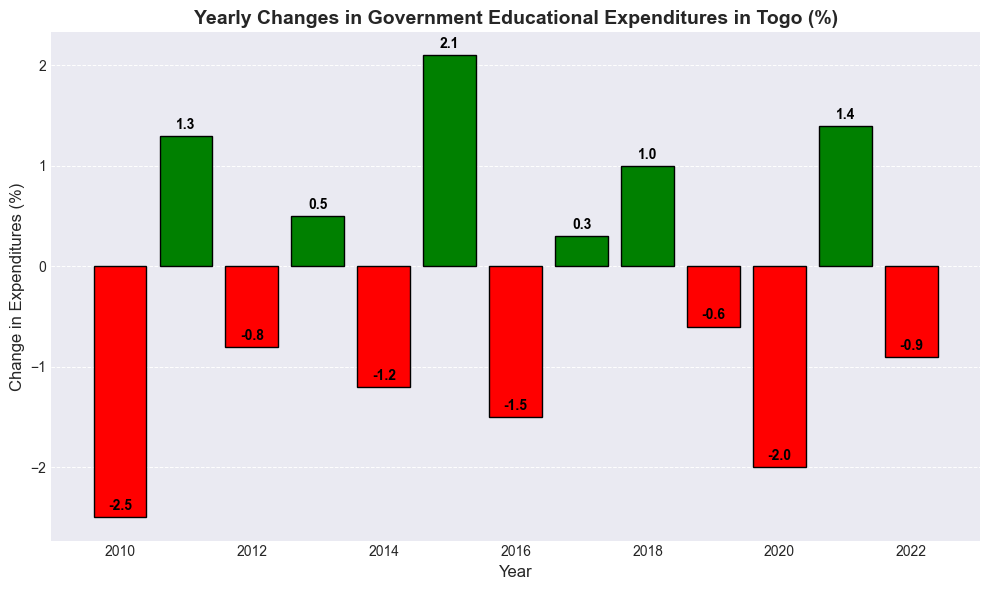Which year experienced the largest negative change in government educational expenditures? By examining the chart, the bar with the lowest height represents the largest negative value. This occurs in 2010 with a change of -2.5%.
Answer: 2010 Which years had positive changes in government educational expenditures consecutively? By looking at the bars in the chart, the years where the expenditures increased consecutively are from 2011 to 2013 and from 2017 to 2018. Thus, the period with consecutive positive changes is from 2011 to 2013.
Answer: 2011-2013 How many years had a decline in government educational expenditures? Counting the number of bars that are colored in red shows there are 7 years with negative changes (-2.5, -0.8, -1.2, -1.5, -0.6, -2.0, -0.9) indicating a decline.
Answer: 7 What was the average change in government educational expenditures over the decade (2010-2020)? The changes from 2010 to 2020 are: -2.5, 1.3, -0.8, 0.5, -1.2, 2.1, -1.5, 0.3, 1.0, -0.6, -2.0. Summing these gives -3.4. Dividing by 11 gives -3.4/11 ≈ -0.31.
Answer: -0.31% Which year had the smallest positive change in government educational expenditures? Observing the green bars representing positive changes, the smallest positive change is 2017 with 0.3%.
Answer: 2017 In which year did government educational expenditures decrease more than it did in 2022? Comparing the red bars, the years with a negative change greater than -0.9% in 2022 are 2010 with -2.5%, 2016 with -1.5%, and 2020 with -2.0%.
Answer: 2010, 2016, 2020 Which year showed the highest increase in educational expenditures? The tallest green bar represents the highest increase, which occurs in 2015 with an increase of 2.1%.
Answer: 2015 What is the total change in government educational expenditures from 2010 to 2015? The changes from 2010 to 2015 are -2.5%, 1.3%, -0.8%, 0.5%, -1.2%, and 2.1%. Summing these, -2.5 + 1.3 - 0.8 + 0.5 - 1.2 + 2.1 = -0.6.
Answer: -0.6% Which years had no significant changes (less than ±0.5%) in educational expenditures? By examining the bars with absolute values less than 0.5, 2012 (-0.8%), 2017 (0.3%), and 2013 (0.5%) fit the criteria.
Answer: 2013, 2017 